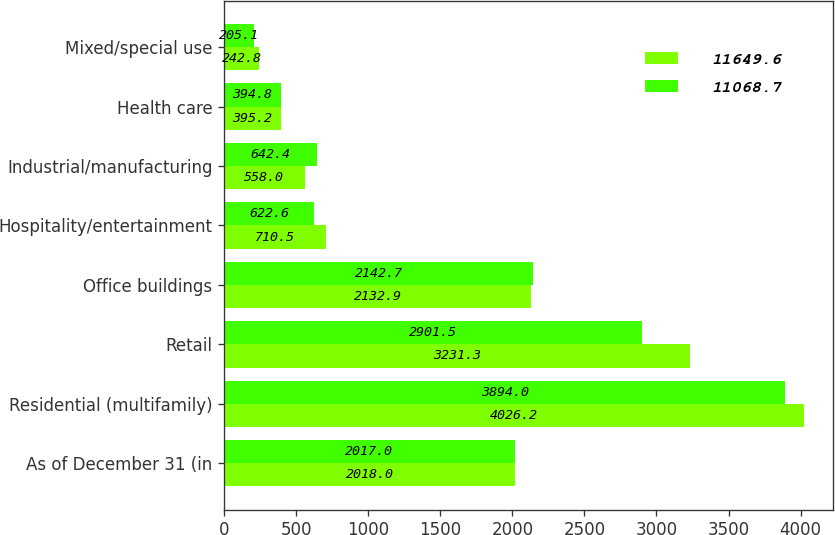Convert chart. <chart><loc_0><loc_0><loc_500><loc_500><stacked_bar_chart><ecel><fcel>As of December 31 (in<fcel>Residential (multifamily)<fcel>Retail<fcel>Office buildings<fcel>Hospitality/entertainment<fcel>Industrial/manufacturing<fcel>Health care<fcel>Mixed/special use<nl><fcel>11649.6<fcel>2018<fcel>4026.2<fcel>3231.3<fcel>2132.9<fcel>710.5<fcel>558<fcel>395.2<fcel>242.8<nl><fcel>11068.7<fcel>2017<fcel>3894<fcel>2901.5<fcel>2142.7<fcel>622.6<fcel>642.4<fcel>394.8<fcel>205.1<nl></chart> 